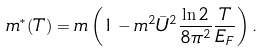<formula> <loc_0><loc_0><loc_500><loc_500>m ^ { \ast } ( T ) = m \left ( 1 - m ^ { 2 } { \bar { U } } ^ { 2 } \frac { \ln 2 } { 8 \pi ^ { 2 } } \frac { T } { E _ { F } } \right ) .</formula> 